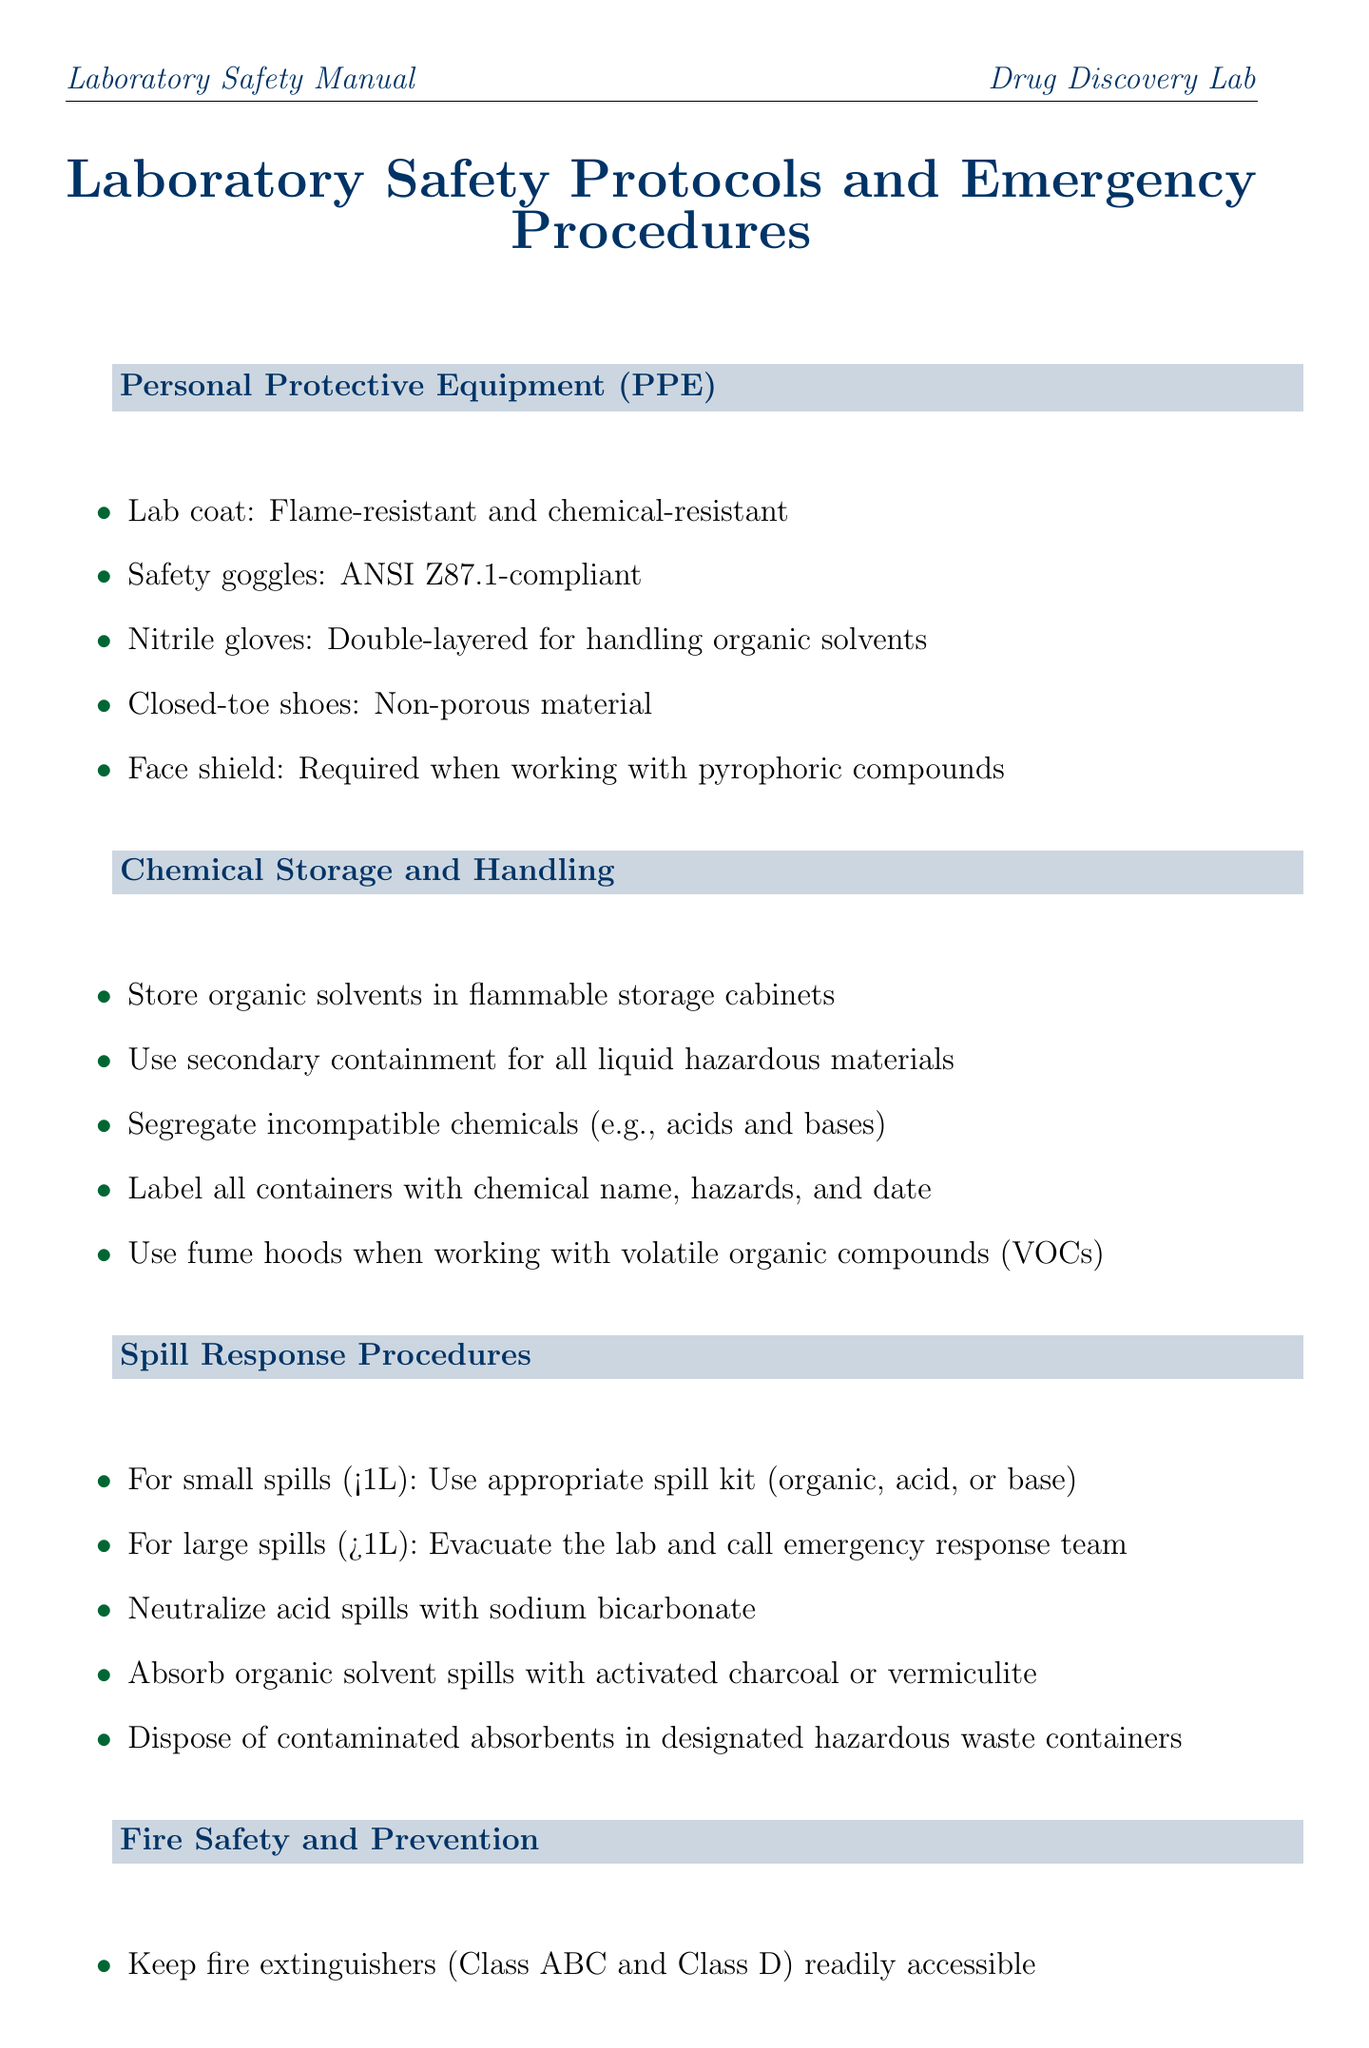What type of gloves are recommended for handling organic solvents? The document specifies that double-layered nitrile gloves are recommended for handling organic solvents.
Answer: Nitrile gloves What is required when working with pyrophoric compounds? The document states that a face shield is required when working with pyrophoric compounds.
Answer: Face shield What is the first action to take in case of a fire? In case of fire, the first action mentioned is to activate the fire alarm.
Answer: Activate fire alarm What should be done with small spills? For small spills, the document advises using the appropriate spill kit (organic, acid, or base).
Answer: Use appropriate spill kit How often should lab safety training be completed? The document specifies that mandatory lab safety training should be completed annually.
Answer: Annually Where should organic solvents be stored? The document indicates that organic solvents should be stored in flammable storage cabinets.
Answer: Flammable storage cabinets What comes after labeling waste containers? The next step after labeling waste containers is to never dispose of organic solvents or reaction mixtures in the sink.
Answer: Never dispose of organic solvents What should be conducted regularly for safety equipment? The document recommends conducting regular inspections of electrical equipment and gas lines for safety.
Answer: Regular inspections 